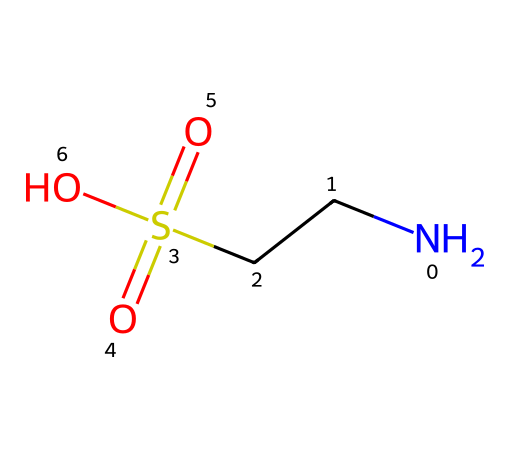What is the main functional group present in taurine? The structural formula shows a sulfonic acid group (−SO3H) attached to the carbon chain, indicating that taurine features a sulfonic acid functional group.
Answer: sulfonic acid How many sulfur atoms are in taurine? The SMILES representation contains one 'S' symbol indicating the presence of a single sulfur atom in the compound.
Answer: one What is the total number of oxygen atoms in taurine? By examining the chemical structure, there are three 'O' symbols present in the SMILES, which indicates that taurine has three oxygen atoms.
Answer: three Does taurine contain any nitrogen atoms? The presence of 'N' in the SMILES representation indicates one nitrogen atom is part of the taurine structure.
Answer: one What type of compound is taurine classified as? Taurine contains a sulfur atom along with carbon, nitrogen, and oxygen, categorizing it as an organosulfur compound because of its sulfur content and overall structure.
Answer: organosulfur How many total atoms are in the taurine molecule? Counting the atoms from the SMILES representation, there are a total of 6 atoms: 2 nitrogen (N), 1 sulfur (S), and 3 oxygen (O) plus 2 carbon (C), leading to a total count of 6.
Answer: six What does the presence of the sulfonic group imply about taurine’s solubility? The presence of the sulfonic acid group suggests that taurine is highly soluble in water due to its polar nature and ability to ionize.
Answer: high solubility 